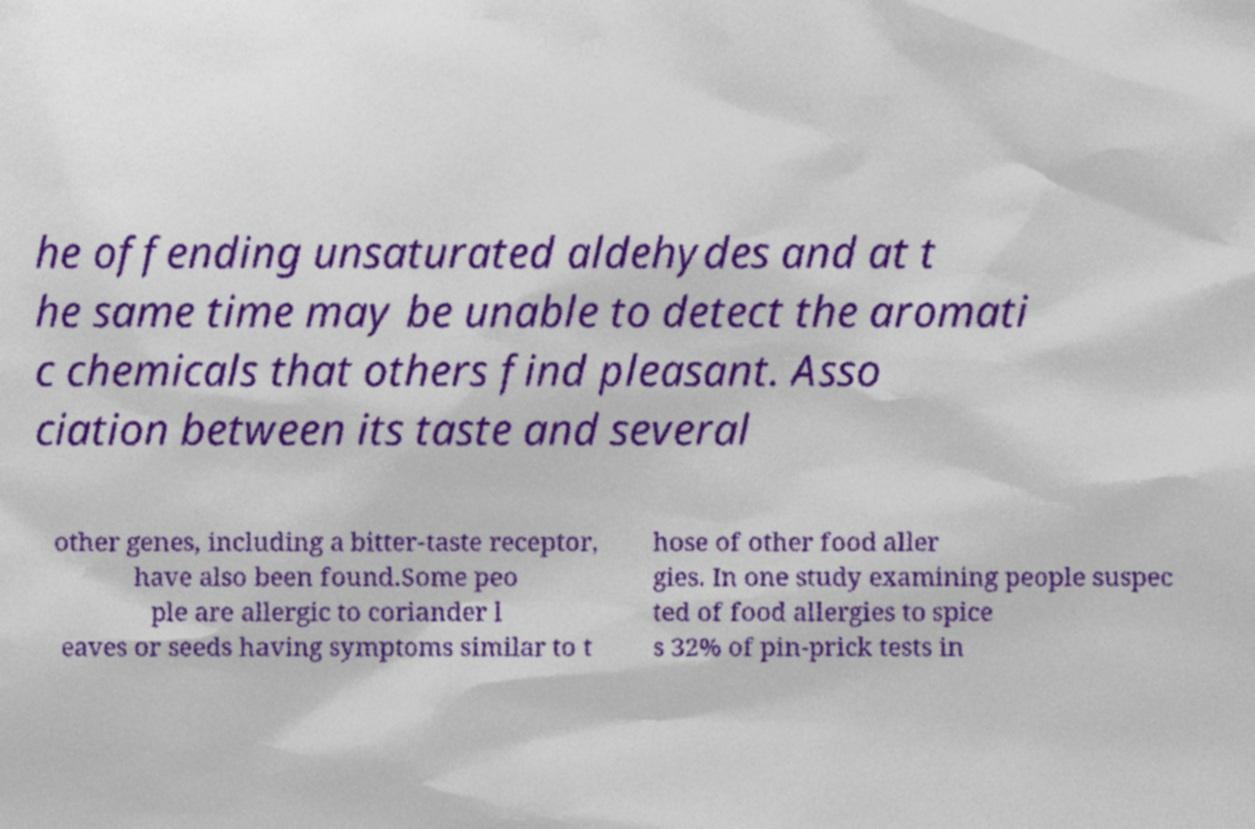Can you read and provide the text displayed in the image?This photo seems to have some interesting text. Can you extract and type it out for me? he offending unsaturated aldehydes and at t he same time may be unable to detect the aromati c chemicals that others find pleasant. Asso ciation between its taste and several other genes, including a bitter-taste receptor, have also been found.Some peo ple are allergic to coriander l eaves or seeds having symptoms similar to t hose of other food aller gies. In one study examining people suspec ted of food allergies to spice s 32% of pin-prick tests in 